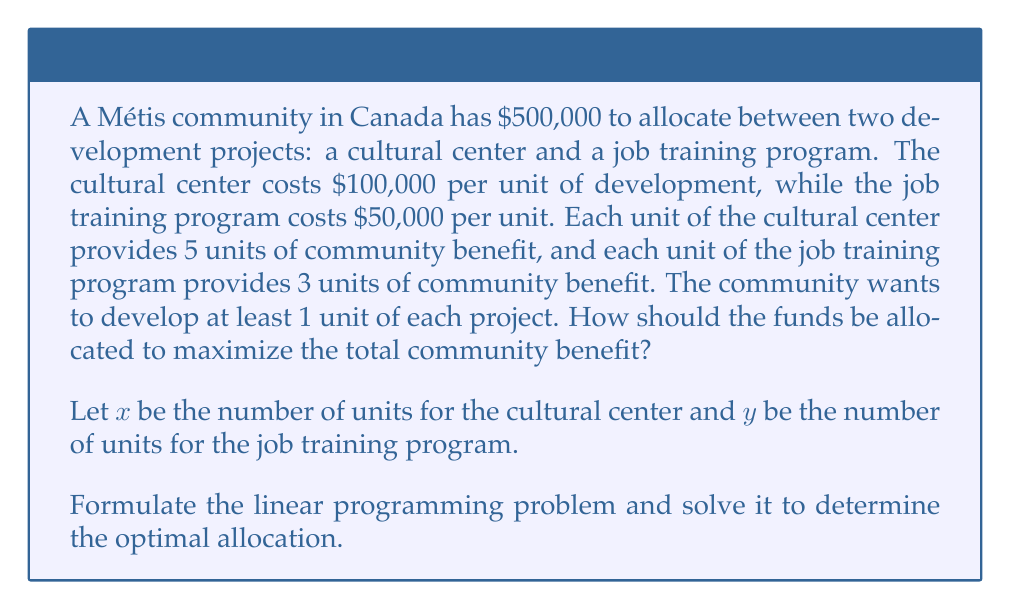Can you solve this math problem? Let's approach this step-by-step:

1) First, we need to formulate the linear programming problem:

   Maximize: $5x + 3y$ (total community benefit)
   Subject to:
   $100,000x + 50,000y \leq 500,000$ (budget constraint)
   $x \geq 1$ (minimum 1 unit of cultural center)
   $y \geq 1$ (minimum 1 unit of job training program)
   $x, y \geq 0$ (non-negativity constraints)

2) We can simplify the budget constraint:
   $2x + y \leq 10$

3) To solve this, we'll use the corner point method. The feasible region is bounded by:
   $2x + y = 10$
   $x = 1$
   $y = 1$

4) The corner points are:
   (1, 1), (1, 8), (4.5, 1)

5) Let's evaluate the objective function at each point:
   At (1, 1): $5(1) + 3(1) = 8$
   At (1, 8): $5(1) + 3(8) = 29$
   At (4.5, 1): $5(4.5) + 3(1) = 25.5$

6) The maximum value occurs at (1, 8), which means:
   1 unit of cultural center
   8 units of job training program

7) This allocation uses the full budget:
   $100,000(1) + 50,000(8) = 500,000$

Therefore, to maximize community benefit, the community should allocate funds for 1 unit of the cultural center and 8 units of the job training program.
Answer: 1 unit of cultural center, 8 units of job training program 